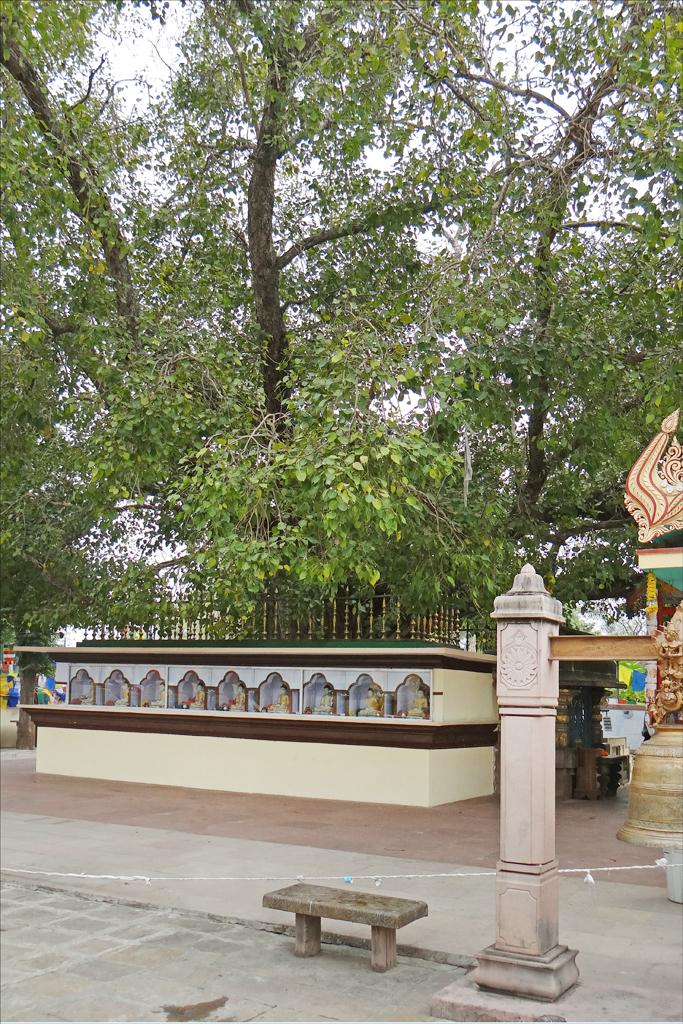What type of wall is present in the image? There is a small yellow wall in the image. What is attached to the wall? The wall has an iron fencing grill. What can be seen at the bottom of the image? There is a concrete pole in the front bottom side of the image. What is located on the ground in the image? There is a small table on the ground. What is visible in the background of the image? There are trees visible in the background of the image. What type of liquid is being poured from the bucket in the image? There is no bucket or liquid present in the image. 